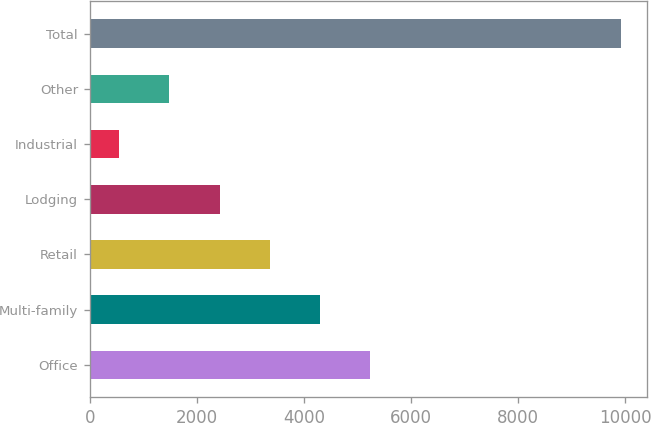Convert chart. <chart><loc_0><loc_0><loc_500><loc_500><bar_chart><fcel>Office<fcel>Multi-family<fcel>Retail<fcel>Lodging<fcel>Industrial<fcel>Other<fcel>Total<nl><fcel>5233.5<fcel>4297.2<fcel>3360.9<fcel>2424.6<fcel>552<fcel>1488.3<fcel>9915<nl></chart> 